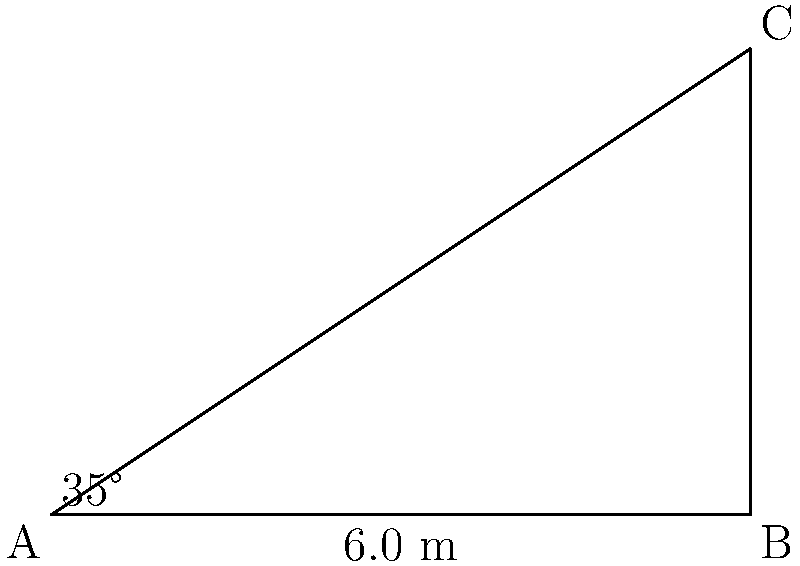At the 1997 Rally Australia, you noticed a new viewing platform at one of the special stages. From the ground, you measure the distance to the base of the platform to be 6.0 meters. Using an inclinometer, you determine the angle of elevation to the top of the platform is 35°. What is the height of the viewing platform? To solve this problem, we'll use right-angled triangle trigonometry. Let's approach this step-by-step:

1) We have a right-angled triangle where:
   - The adjacent side (ground distance) is 6.0 meters
   - The angle of elevation is 35°
   - We need to find the opposite side (height of the platform)

2) In this case, we need to use the tangent function, as it relates the opposite and adjacent sides:

   $\tan(\theta) = \frac{\text{opposite}}{\text{adjacent}}$

3) Let's plug in our known values:

   $\tan(35°) = \frac{\text{height}}{6.0}$

4) To solve for the height, we multiply both sides by 6.0:

   $6.0 \times \tan(35°) = \text{height}$

5) Now we can calculate:
   
   $\text{height} = 6.0 \times \tan(35°)$
   $\text{height} = 6.0 \times 0.7002$
   $\text{height} = 4.2012$ meters

6) Rounding to one decimal place (as the given measurement was to one decimal place):

   $\text{height} \approx 4.2$ meters

Thus, the viewing platform is approximately 4.2 meters high.
Answer: 4.2 meters 